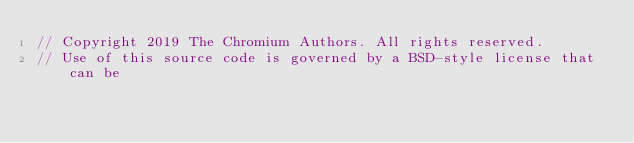Convert code to text. <code><loc_0><loc_0><loc_500><loc_500><_ObjectiveC_>// Copyright 2019 The Chromium Authors. All rights reserved.
// Use of this source code is governed by a BSD-style license that can be</code> 